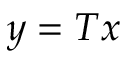Convert formula to latex. <formula><loc_0><loc_0><loc_500><loc_500>y = T x</formula> 